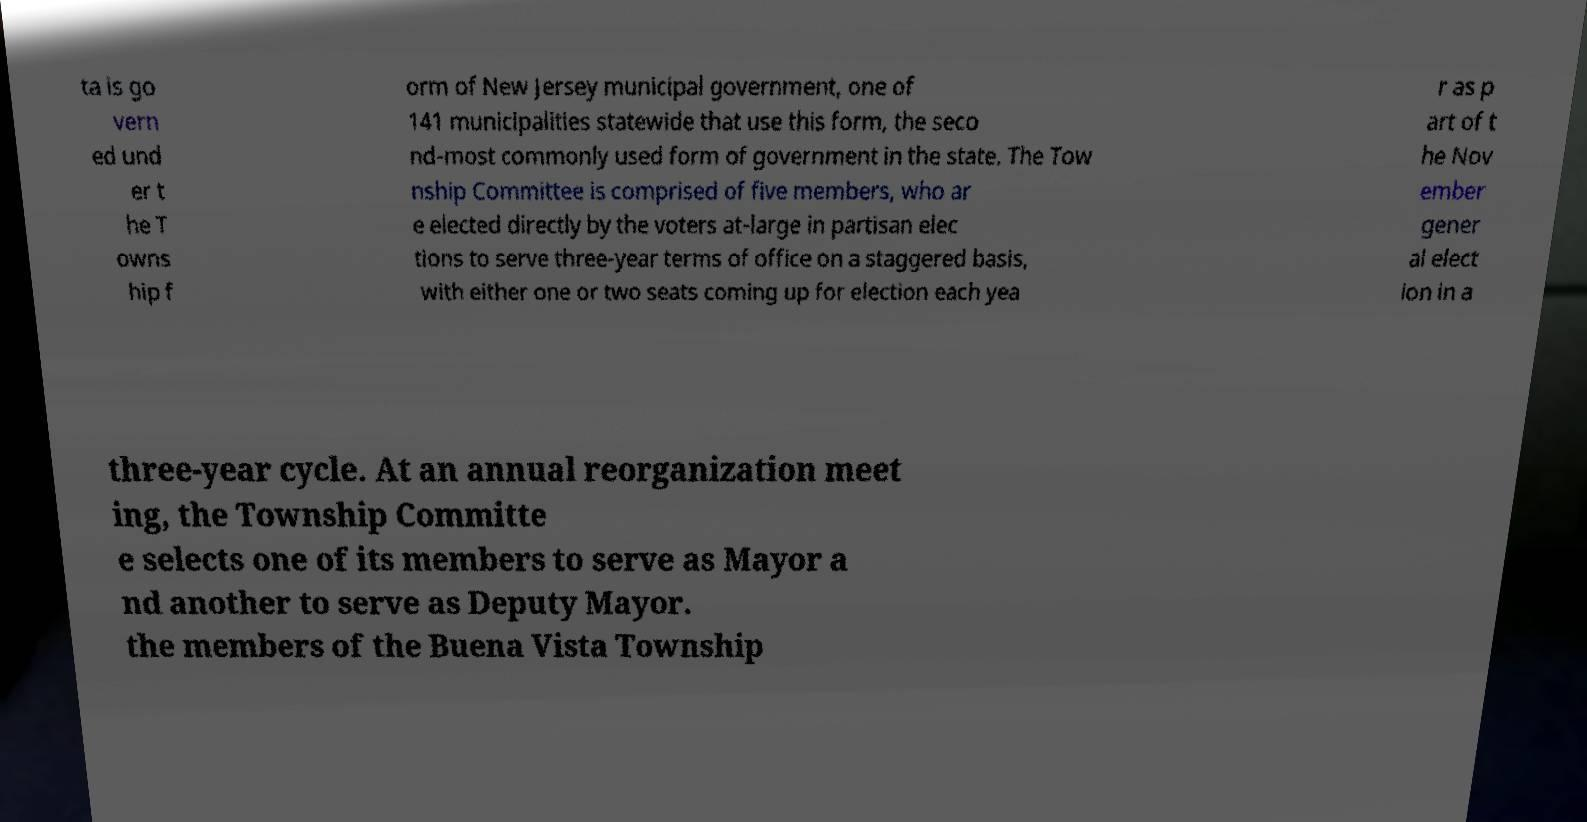What messages or text are displayed in this image? I need them in a readable, typed format. ta is go vern ed und er t he T owns hip f orm of New Jersey municipal government, one of 141 municipalities statewide that use this form, the seco nd-most commonly used form of government in the state. The Tow nship Committee is comprised of five members, who ar e elected directly by the voters at-large in partisan elec tions to serve three-year terms of office on a staggered basis, with either one or two seats coming up for election each yea r as p art of t he Nov ember gener al elect ion in a three-year cycle. At an annual reorganization meet ing, the Township Committe e selects one of its members to serve as Mayor a nd another to serve as Deputy Mayor. the members of the Buena Vista Township 